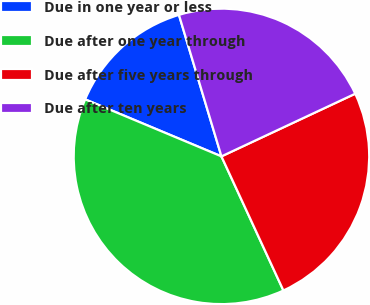Convert chart. <chart><loc_0><loc_0><loc_500><loc_500><pie_chart><fcel>Due in one year or less<fcel>Due after one year through<fcel>Due after five years through<fcel>Due after ten years<nl><fcel>14.05%<fcel>38.19%<fcel>25.08%<fcel>22.67%<nl></chart> 